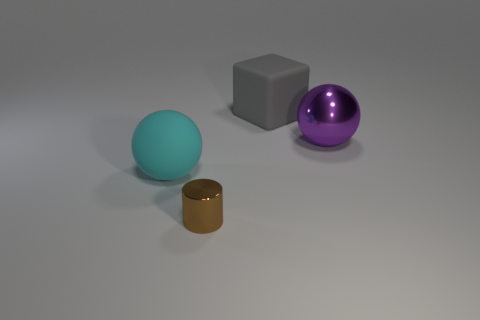Add 1 large gray cylinders. How many objects exist? 5 Subtract all cylinders. How many objects are left? 3 Subtract all small metallic things. Subtract all big spheres. How many objects are left? 1 Add 1 cubes. How many cubes are left? 2 Add 4 shiny spheres. How many shiny spheres exist? 5 Subtract 0 red balls. How many objects are left? 4 